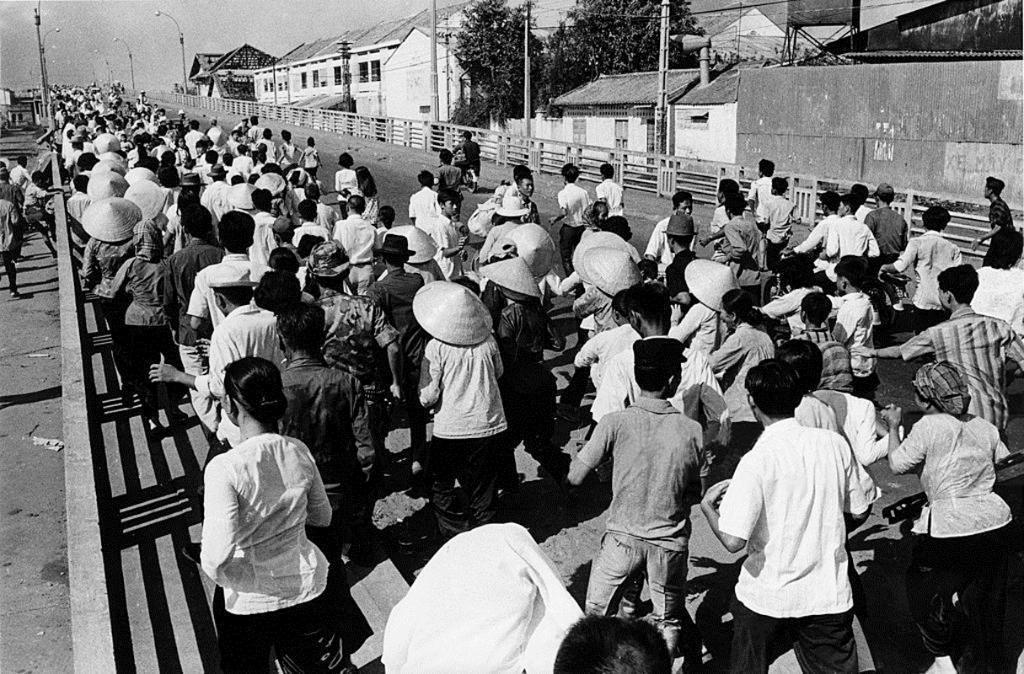Please provide a concise description of this image. It is a black and white image there is a crowd moving on the road and in the right side of the road there are a lot of houses and some trees in between those houses. 